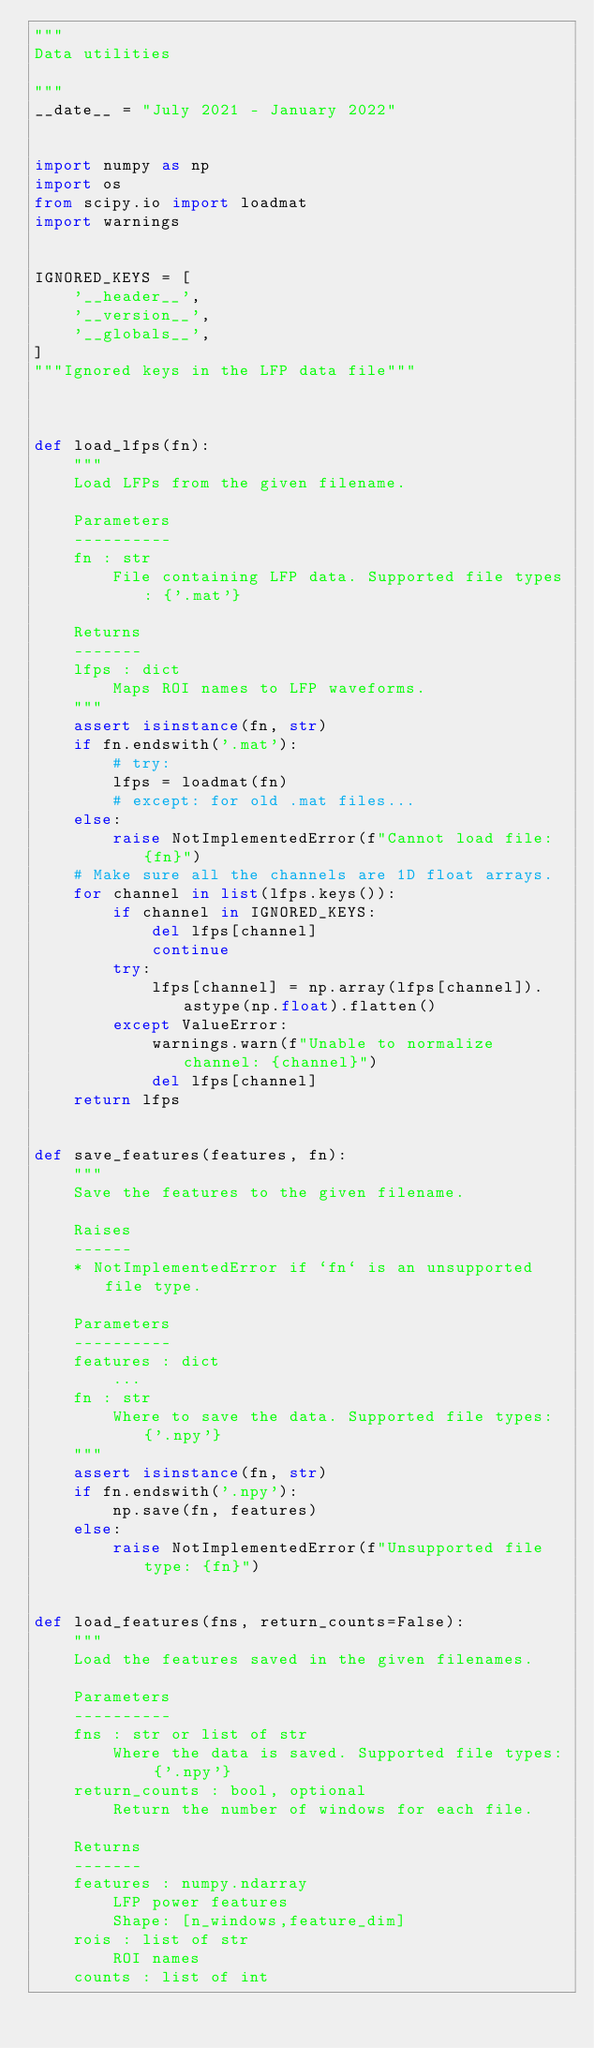<code> <loc_0><loc_0><loc_500><loc_500><_Python_>"""
Data utilities

"""
__date__ = "July 2021 - January 2022"


import numpy as np
import os
from scipy.io import loadmat
import warnings


IGNORED_KEYS = [
    '__header__',
    '__version__',
    '__globals__',
]
"""Ignored keys in the LFP data file"""



def load_lfps(fn):
    """
    Load LFPs from the given filename.

    Parameters
    ----------
    fn : str
        File containing LFP data. Supported file types: {'.mat'}

    Returns
    -------
    lfps : dict
        Maps ROI names to LFP waveforms.
    """
    assert isinstance(fn, str)
    if fn.endswith('.mat'):
        # try:
        lfps = loadmat(fn)
        # except: for old .mat files...
    else:
        raise NotImplementedError(f"Cannot load file: {fn}")
    # Make sure all the channels are 1D float arrays.
    for channel in list(lfps.keys()):
        if channel in IGNORED_KEYS:
            del lfps[channel]
            continue
        try:
            lfps[channel] = np.array(lfps[channel]).astype(np.float).flatten()
        except ValueError:
            warnings.warn(f"Unable to normalize channel: {channel}")
            del lfps[channel]
    return lfps


def save_features(features, fn):
    """
    Save the features to the given filename.

    Raises
    ------
    * NotImplementedError if `fn` is an unsupported file type.

    Parameters
    ----------
    features : dict
        ...
    fn : str
        Where to save the data. Supported file types: {'.npy'}
    """
    assert isinstance(fn, str)
    if fn.endswith('.npy'):
        np.save(fn, features)
    else:
        raise NotImplementedError(f"Unsupported file type: {fn}")


def load_features(fns, return_counts=False):
    """
    Load the features saved in the given filenames.

    Parameters
    ----------
    fns : str or list of str
        Where the data is saved. Supported file types: {'.npy'}
    return_counts : bool, optional
        Return the number of windows for each file.

    Returns
    -------
    features : numpy.ndarray
        LFP power features
        Shape: [n_windows,feature_dim]
    rois : list of str
        ROI names
    counts : list of int</code> 